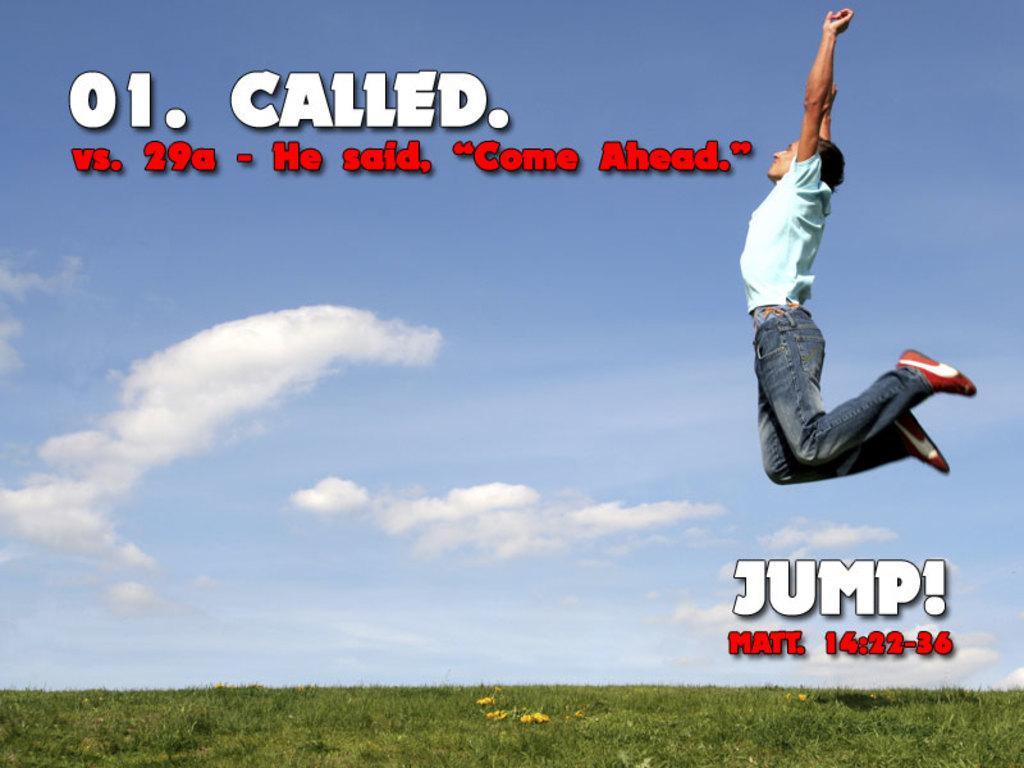Describe this image in one or two sentences. This image consists of a poster. On the right side I can see a man wearing a t-shirt, jeans and jumping. At the bottom of the image I can see the grass in green color. On the top of the image I can see the sky in blue color and clouds. On this image I can see some text in white and red colors. 